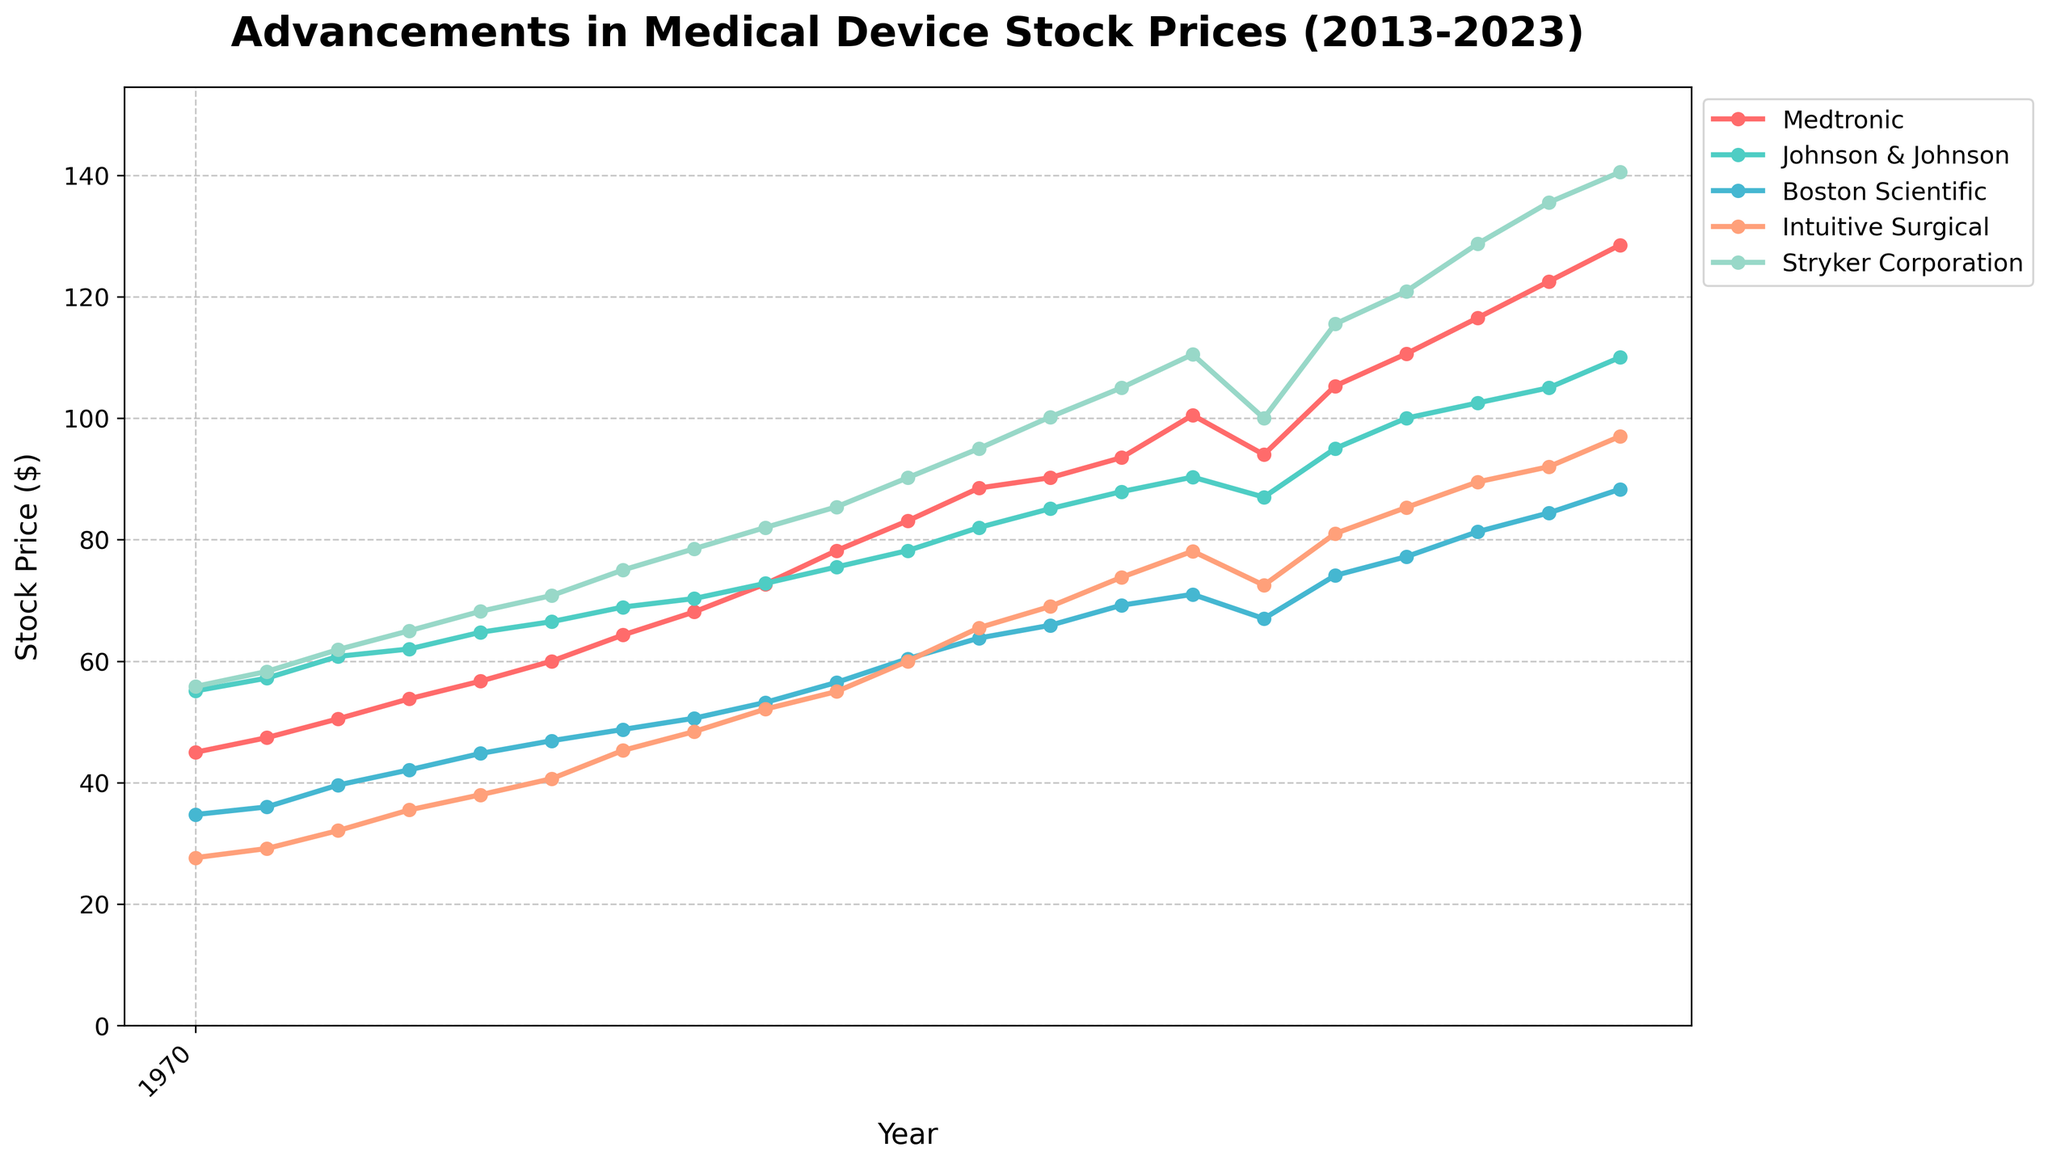What is the title of the plot? The title of the plot is presented at the top of the figure. It reads, "Advancements in Medical Device Stock Prices (2013-2023)"
Answer: Advancements in Medical Device Stock Prices (2013-2023) How many companies' stock prices are plotted in the figure? By examining the legend on the plot, we can see five different company names listed: Medtronic, Johnson & Johnson, Boston Scientific, Intuitive Surgical, and Stryker Corporation.
Answer: 5 What was the stock price for Intuitive Surgical in January 2017? Locate the marker corresponding to January 2017 on the x-axis for Intuitive Surgical, which is represented by a specific color (denoted in the legend). The y-axis value at this point should be checked.
Answer: 52.10 Which company had the highest stock price in January 2023? Identify the stock prices for all companies in January 2023 by locating the respective markers. Compare these values to determine the highest one. Stryker Corporation had the highest stock price at that time.
Answer: Stryker Corporation Between June 2020 and January 2021, which company showed the greatest increase in stock price? Observe the stock prices of all companies at June 2020 and January 2021. Calculate the difference for each company and compare these differences.
Answer: Medtronic Which company had the least volatile stock price between January 2013 and January 2023? Determine the stock prices' range (difference between maximum and minimum) for each company over the given period. The company with the smallest range is the least volatile. Based on examination, Johnson & Johnson had the least volatility.
Answer: Johnson & Johnson Between 2013 and 2023, in what year did Medtronic experience the most significant increase in stock price? Identify the stock price of Medtronic for each year and calculate the year-on-year increase. The year with the largest increase (difference between consecutive years) indicates the most significant rise.
Answer: 2021 How does the stock price trend of Boston Scientific compare to Stryker Corporation's trend over the years? By comparing the lines representing Boston Scientific and Stryker Corporation from 2013 to 2023, check the overall upward or downward trend. Both companies exhibit an upward trend, but Stryker Corporation shows a much sharper increase over the period.
Answer: Both are upward, with Stryker's trend being steeper Did any company experience a significant dip in 2020? Which one? Examine the stock prices for all companies in 2020 and look for a notable drop compared to adjacent data points. Medtronic's stock price significantly dipped in mid-2020 before recovering.
Answer: Medtronic 